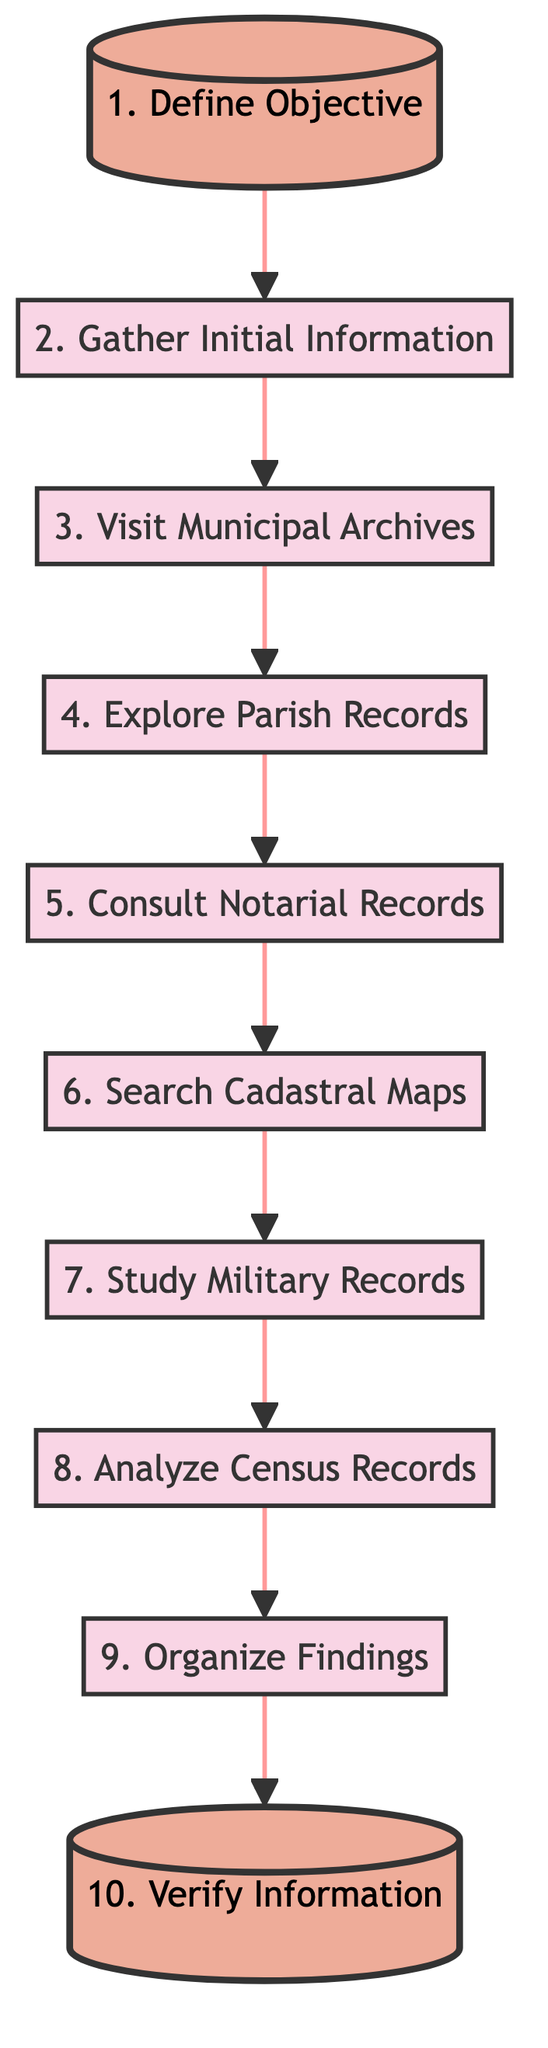What is the first step in tracing family genealogy? The first step is represented by node A, which is titled "Define Objective." This step sets the foundation for what family lines and time periods the person will research.
Answer: Define Objective How many total steps are there in the diagram? By counting each step represented in the diagram from 1 to 10, we determine that there are a total of 10 steps.
Answer: 10 What step does one need to complete before visiting municipal archives? The diagram shows that one must complete step 2, "Gather Initial Information," before moving on to step 3, which is "Visit Municipal Archives."
Answer: Gather Initial Information Which step follows exploring parish records? The flow chart indicates that after completing step 4, "Explore Parish Records," the next step would be step 5, "Consult Notarial Records."
Answer: Consult Notarial Records What type of records is examined in step 7? Step 7, "Study Military Records," focuses on looking up military-related documents, such as conscription and military service records.
Answer: Military Records Which two steps are directly connected by an edge? The diagram shows connections between various steps. For example, step 1, "Define Objective," is directly connected to step 2, "Gather Initial Information." This can also be seen with other adjacent steps.
Answer: Define Objective and Gather Initial Information What is the last step in the genealogy tracing process? The last step, represented by node J, is titled "Verify Information." This step emphasizes the importance of cross-checking facts with multiple sources.
Answer: Verify Information How does one finalize their findings according to the diagram? According to the diagram, findings are finalized in step 9, "Organize Findings," where one compiles and digitizes documents to create a family tree.
Answer: Organize Findings What is the title of step 6? Step 6, as indicated in the diagram, is titled "Search Cadastral Maps," which involves reviewing land ownership maps.
Answer: Search Cadastral Maps 